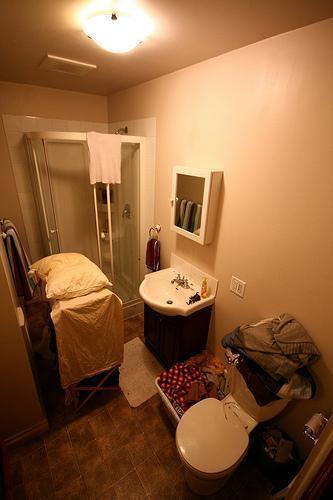How many sinks?
Give a very brief answer. 1. 